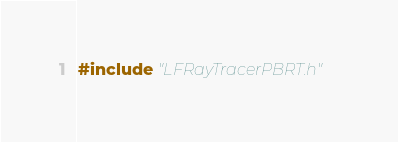<code> <loc_0><loc_0><loc_500><loc_500><_C++_>#include "LFRayTracerPBRT.h"
</code> 